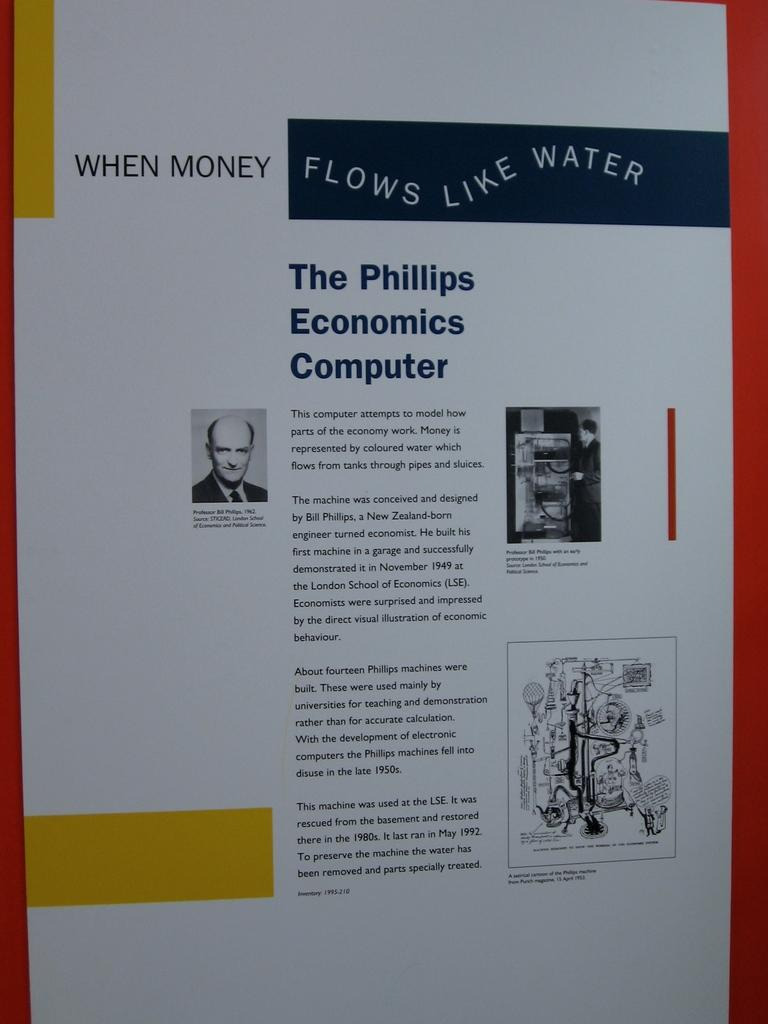<image>
Present a compact description of the photo's key features. An article of one of the first computers called The Phillips Economics Computer. 